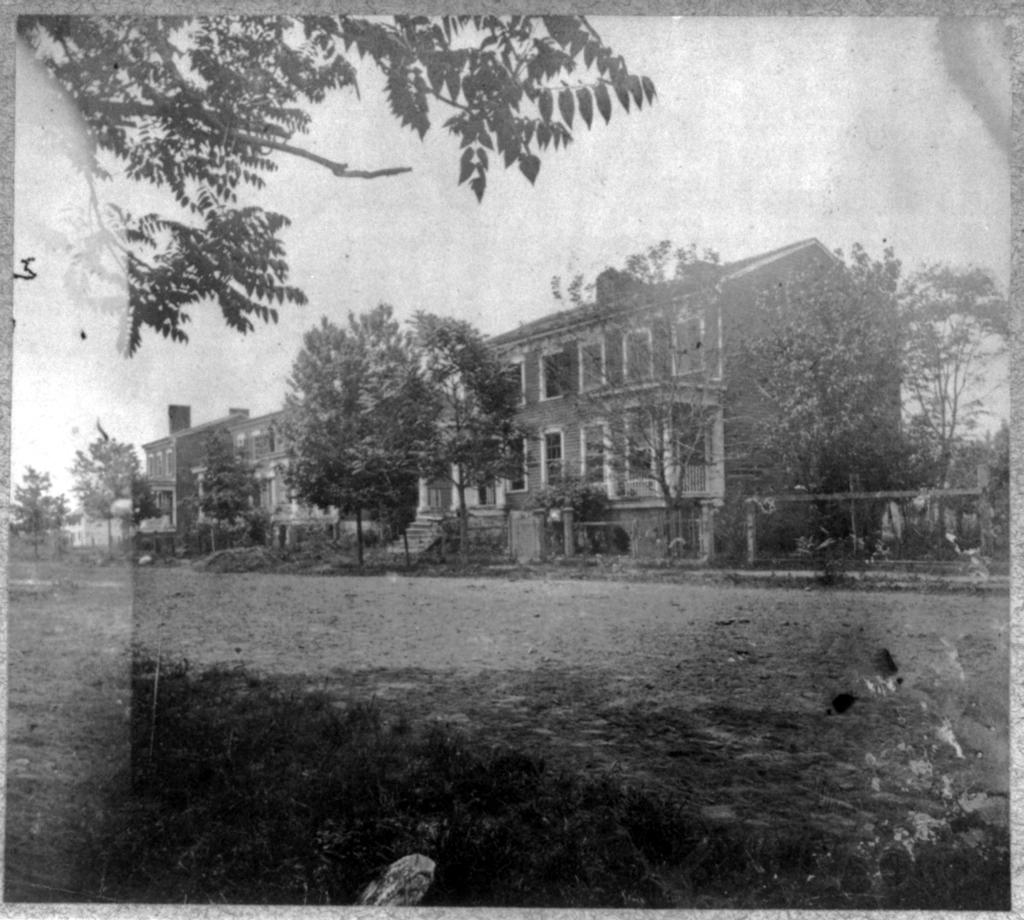What type of structure can be seen in the image? There is a building in the image. What other natural elements are present in the image? There are trees in the image. What is the surface visible in the image? There is ground visible in the image. What type of sponge can be seen bursting in the image? There is no sponge present in the image, nor is there any indication of something bursting. 